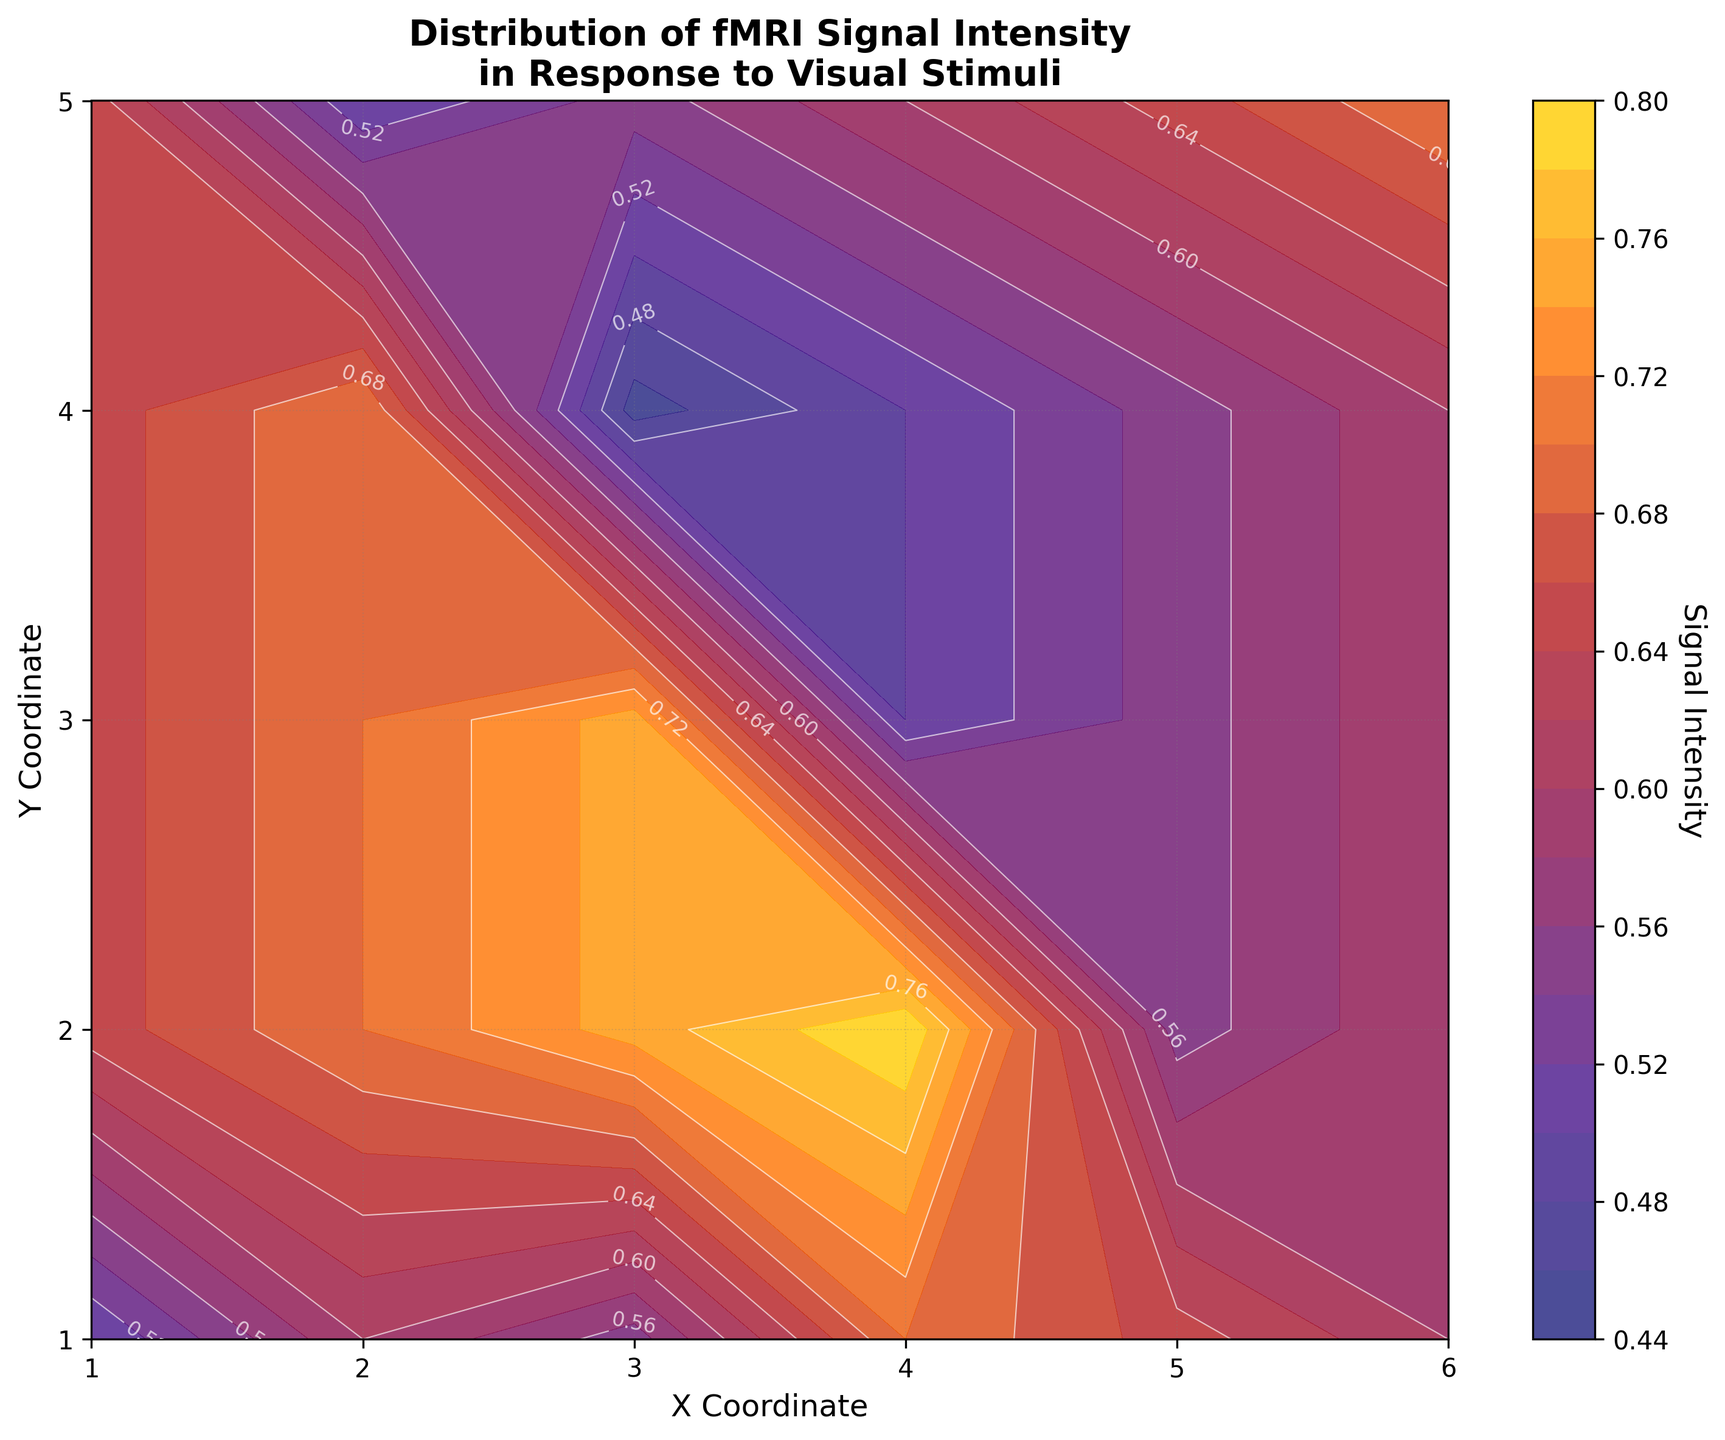Where are the highest signal intensity values located on the plot? The highest signal intensity values are represented by the yellow color. Observing the color gradient, the highest values are located near the top-right corner of the plot.
Answer: Top-right corner What is the title of the plot? The title is prominently displayed at the top of the plot and reads, "Distribution of fMRI Signal Intensity in Response to Visual Stimuli."
Answer: Distribution of fMRI Signal Intensity in Response to Visual Stimuli Which contour lines on the plot indicate areas with a signal intensity of 0.60? The contour lines are marked with their corresponding values. You can find the lines labeled "0.60" throughout the middle areas of the plot, particularly running diagonally from the bottom-left to the top-right.
Answer: Middle areas, diagonal from bottom-left to top-right Compare the signal intensity values at coordinates (1, 1) and (5, 5). Which one is higher? By examining the color-coded contour plot, the intensity at (5, 5) is represented with a less intense color than (1, 1). Thus, (1, 1) has a higher signal intensity value.
Answer: (1, 1) What is the signal intensity value at the coordinate (4, 5)? The labeled contour lines and the color gradient around the coordinate indicate that the signal intensity at (4, 5) is approximately 0.70.
Answer: 0.70 Between coordinates (3, 3) and (3, 5), which one has a greater signal intensity? Observing the colors on the contour plot, (3, 5) has a more intense color closer to yellow, indicating a higher signal intensity than (3, 3).
Answer: (3, 5) What is the range of signal intensity values shown in the plot? By looking at the colorbar on the right of the plot, the range is identified from the lowest value depicted in dark blue at approximately 0.45 to the highest value in bright yellow at about 0.80.
Answer: 0.45 to 0.80 Is the signal intensity more uniformly distributed along the x-axis or the y-axis? Observing the contour lines' density and color changes, there is a more noticeable gradient and variation along the y-axis compared to the x-axis, suggesting a less uniform distribution along the y-axis.
Answer: Y-axis What signal intensity value is represented by the contour lines that are closer to the white label 0.75? The contour lines with the white label of 0.75 denote areas generally near the top and middle-right region of the plot, aligning with the lighter colors.
Answer: 0.75 